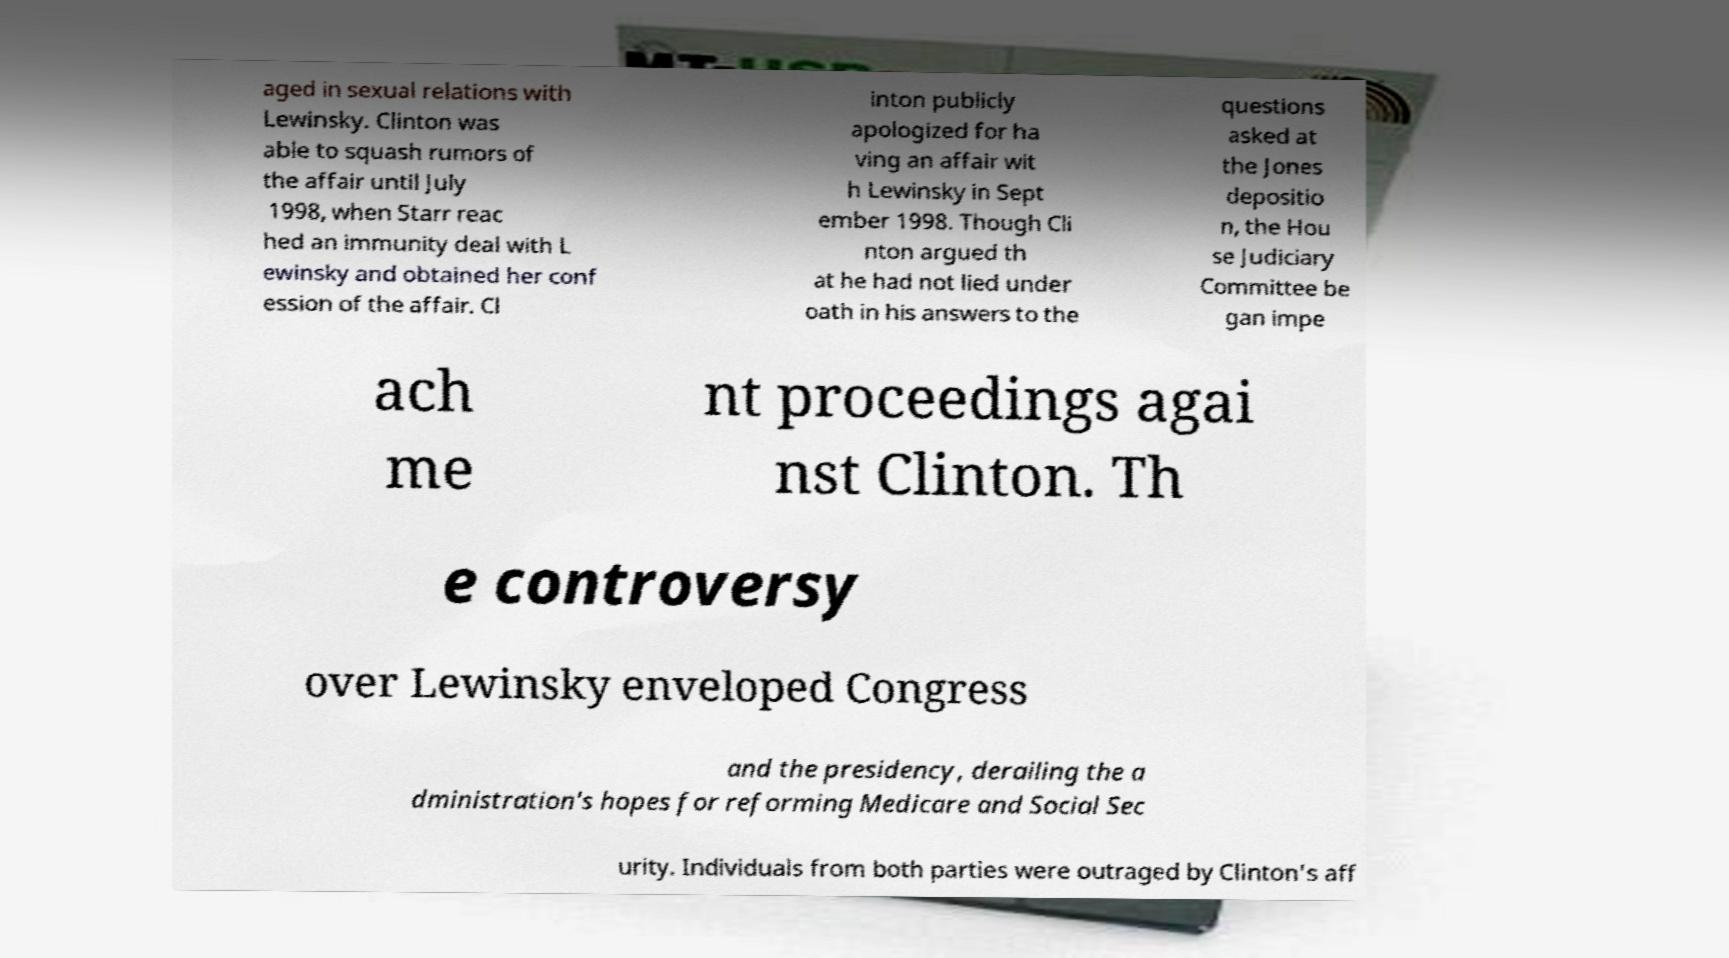For documentation purposes, I need the text within this image transcribed. Could you provide that? aged in sexual relations with Lewinsky. Clinton was able to squash rumors of the affair until July 1998, when Starr reac hed an immunity deal with L ewinsky and obtained her conf ession of the affair. Cl inton publicly apologized for ha ving an affair wit h Lewinsky in Sept ember 1998. Though Cli nton argued th at he had not lied under oath in his answers to the questions asked at the Jones depositio n, the Hou se Judiciary Committee be gan impe ach me nt proceedings agai nst Clinton. Th e controversy over Lewinsky enveloped Congress and the presidency, derailing the a dministration's hopes for reforming Medicare and Social Sec urity. Individuals from both parties were outraged by Clinton's aff 